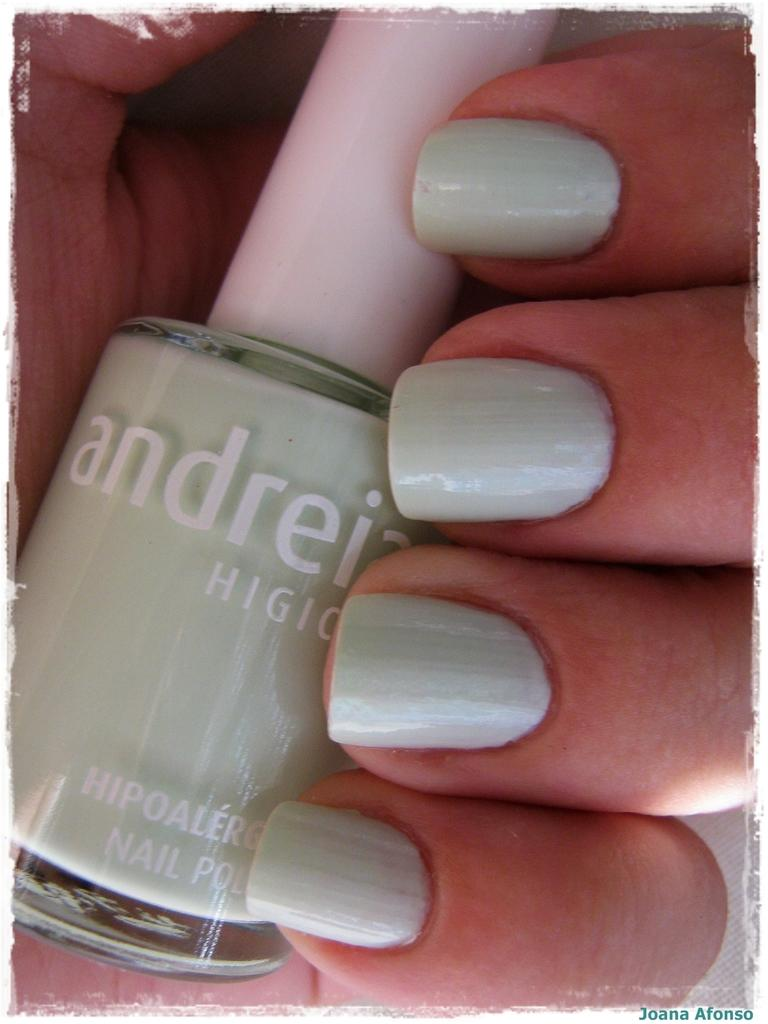<image>
Give a short and clear explanation of the subsequent image. A hand is holding a bottle of hypoallergenic nail polish. 